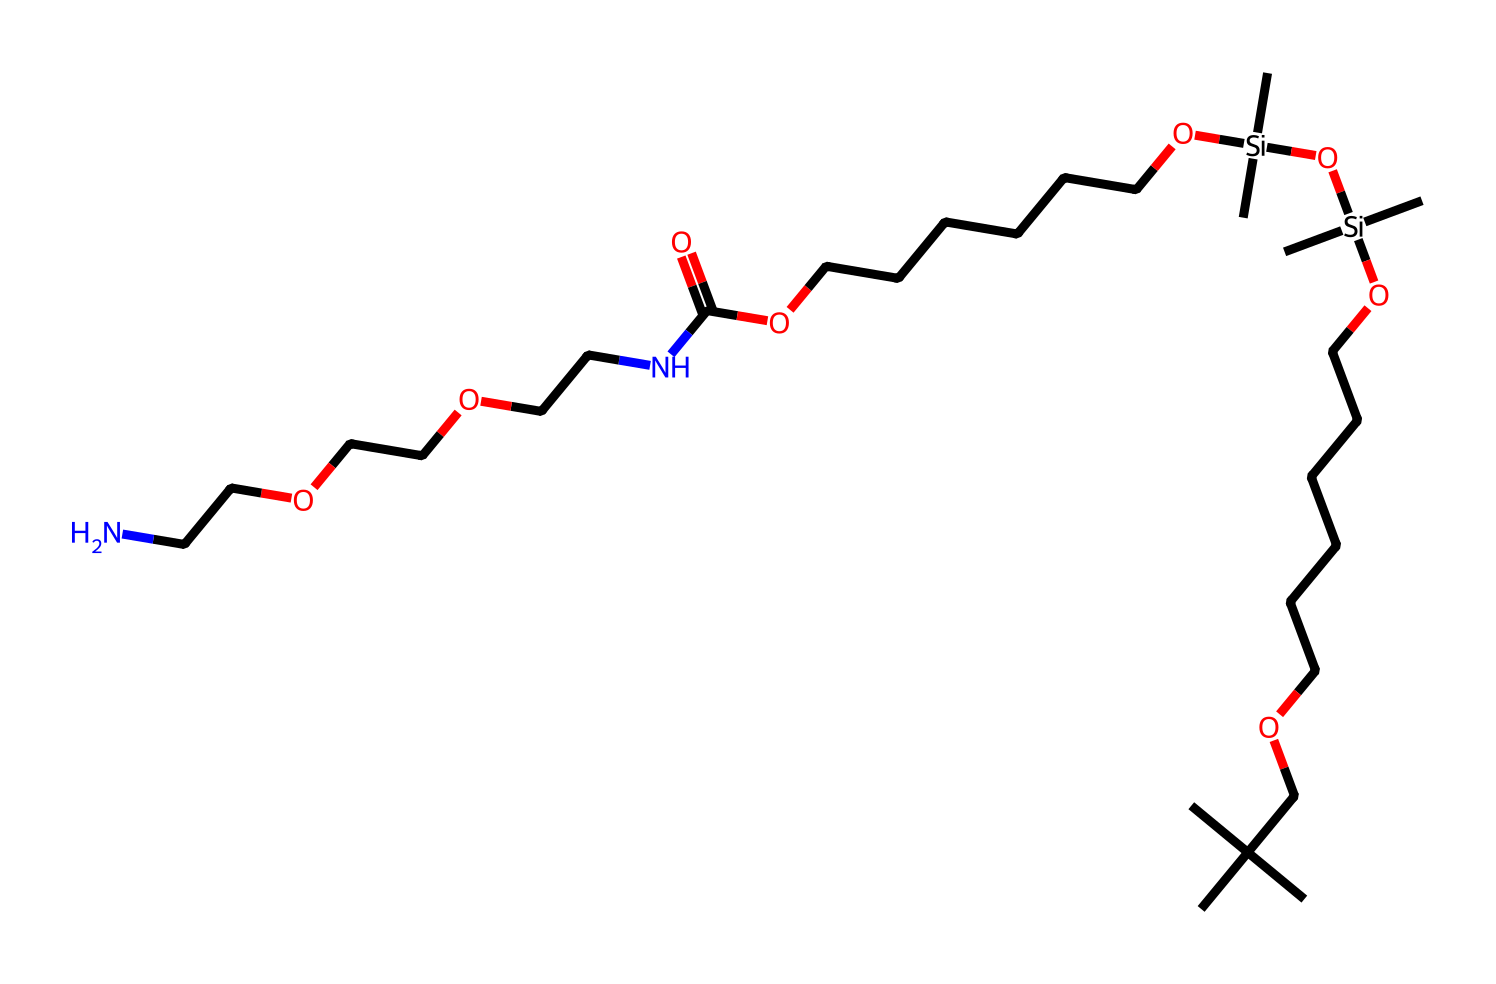What type of polymer is represented in this structure? The structure shown is a polyurethane foam, which contains repeated units formed by isocyanate and polyol reactions. The presence of urethane linkages (–NH–CO–O–) indicates it belongs to this category of polymers.
Answer: polyurethane How many nitrogen atoms are present in the structure? By analyzing the SMILES representation, we can identify two occurrences of "N" corresponding to nitrogen atoms. This leads to a total count of nitrogen atoms present in the chemical structure.
Answer: 2 What element in this structure is responsible for the polymer's flexibility? The presence of long hydrocarbon chains (specifically the multiple "C" groups) contributes to the flexibility of the polyurethane foam, as they allow the material to bend and stretch easily.
Answer: carbon What is the total number of oxygen atoms in this structure? By examining the SMILES notation, each "O" represents an oxygen atom. Counting these reveals a total of six oxygen atoms exist in the molecular composition.
Answer: 6 How many distinct silane groups (Si) are found in the structure? Within the SMILES representation, there are two occurrences of "Si" which indicates two distinct silane groups. These contribute to the material's durability and water resistance.
Answer: 2 What functional group primarily characterizes this polymer? The urethane functional group (–NH–CO–O–) is prominent in this chemical structure. The presence of this group is crucial for defining the properties of polyurethane-based materials.
Answer: urethane 